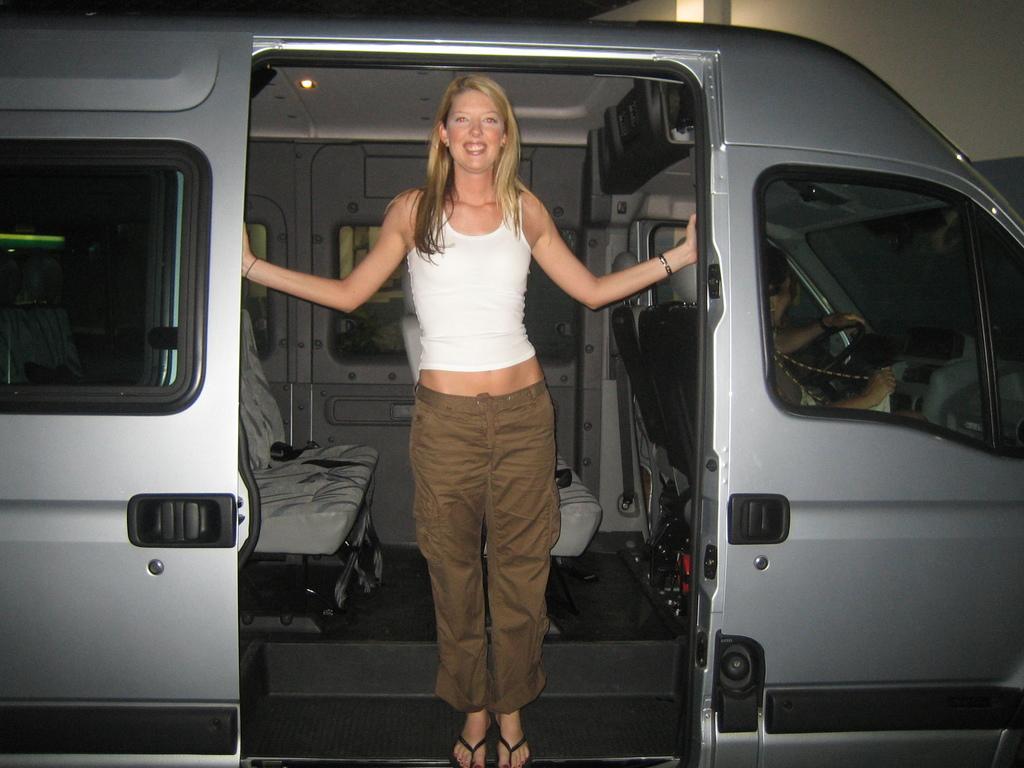Could you give a brief overview of what you see in this image? In the picture we can see woman wearing white color vest, brown color pant standing in a car and we can see a person sitting in driver seat. 